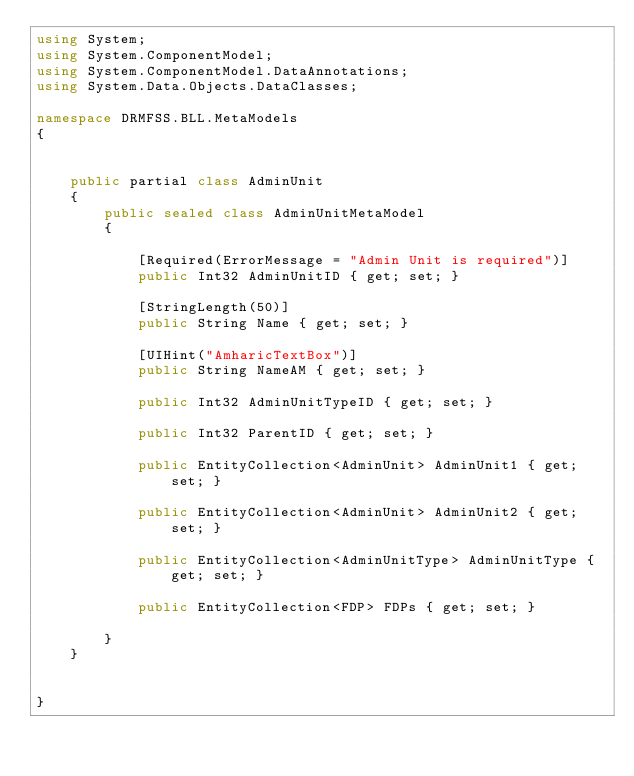Convert code to text. <code><loc_0><loc_0><loc_500><loc_500><_C#_>using System;
using System.ComponentModel;
using System.ComponentModel.DataAnnotations;
using System.Data.Objects.DataClasses;

namespace DRMFSS.BLL.MetaModels
{


    public partial class AdminUnit
    {
        public sealed class AdminUnitMetaModel
        {

            [Required(ErrorMessage = "Admin Unit is required")]
            public Int32 AdminUnitID { get; set; }

            [StringLength(50)]
            public String Name { get; set; }

            [UIHint("AmharicTextBox")]
            public String NameAM { get; set; }

            public Int32 AdminUnitTypeID { get; set; }

            public Int32 ParentID { get; set; }

            public EntityCollection<AdminUnit> AdminUnit1 { get; set; }

            public EntityCollection<AdminUnit> AdminUnit2 { get; set; }

            public EntityCollection<AdminUnitType> AdminUnitType { get; set; }

            public EntityCollection<FDP> FDPs { get; set; }

        }
    }
	
	
}

</code> 